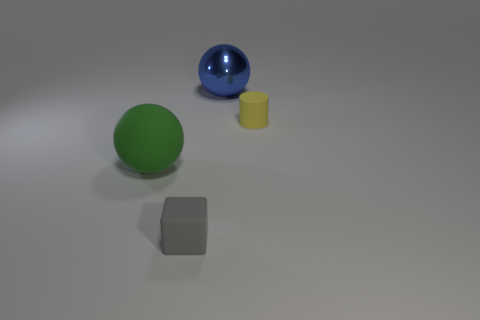Subtract all green spheres. How many spheres are left? 1 Add 3 red metal spheres. How many objects exist? 7 Subtract all cubes. How many objects are left? 3 Add 2 big purple balls. How many big purple balls exist? 2 Subtract 0 cyan cubes. How many objects are left? 4 Subtract all gray balls. Subtract all brown cylinders. How many balls are left? 2 Subtract all tiny yellow metallic spheres. Subtract all small yellow matte objects. How many objects are left? 3 Add 3 yellow objects. How many yellow objects are left? 4 